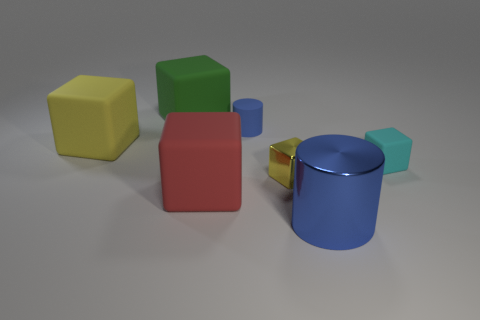Are there any big rubber things of the same color as the tiny matte block?
Make the answer very short. No. What number of big things are either blue matte cylinders or brown shiny blocks?
Provide a short and direct response. 0. What number of large green rubber blocks are there?
Ensure brevity in your answer.  1. What is the yellow thing that is on the right side of the green object made of?
Keep it short and to the point. Metal. Are there any cyan matte cubes right of the big blue cylinder?
Your response must be concise. Yes. Is the metal cube the same size as the blue matte cylinder?
Give a very brief answer. Yes. How many small cubes are the same material as the large yellow object?
Offer a very short reply. 1. There is a blue thing behind the blue object in front of the tiny blue object; how big is it?
Provide a short and direct response. Small. There is a block that is behind the tiny metallic object and to the right of the small matte cylinder; what color is it?
Your answer should be compact. Cyan. Is the green matte object the same shape as the blue metallic thing?
Make the answer very short. No. 